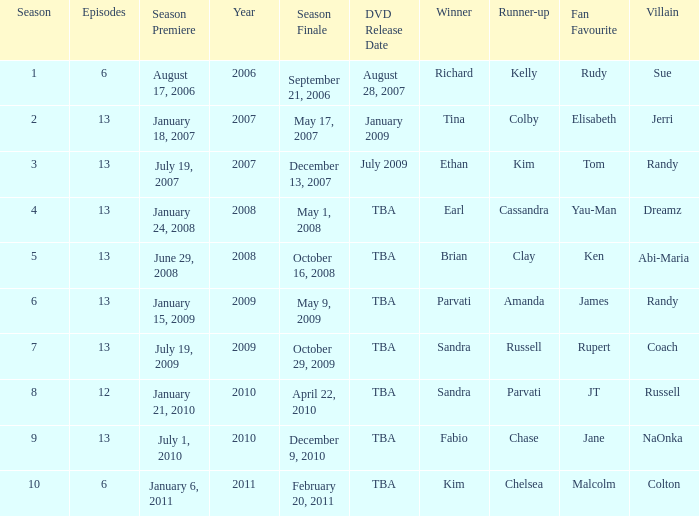On what date was the DVD released for the season with fewer than 13 episodes that aired before season 8? August 28, 2007. 